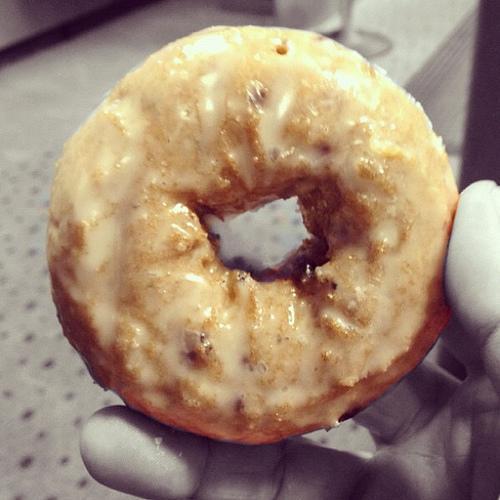How many finger tips are visible?
Give a very brief answer. 2. How many holes does donut have?
Give a very brief answer. 1. 